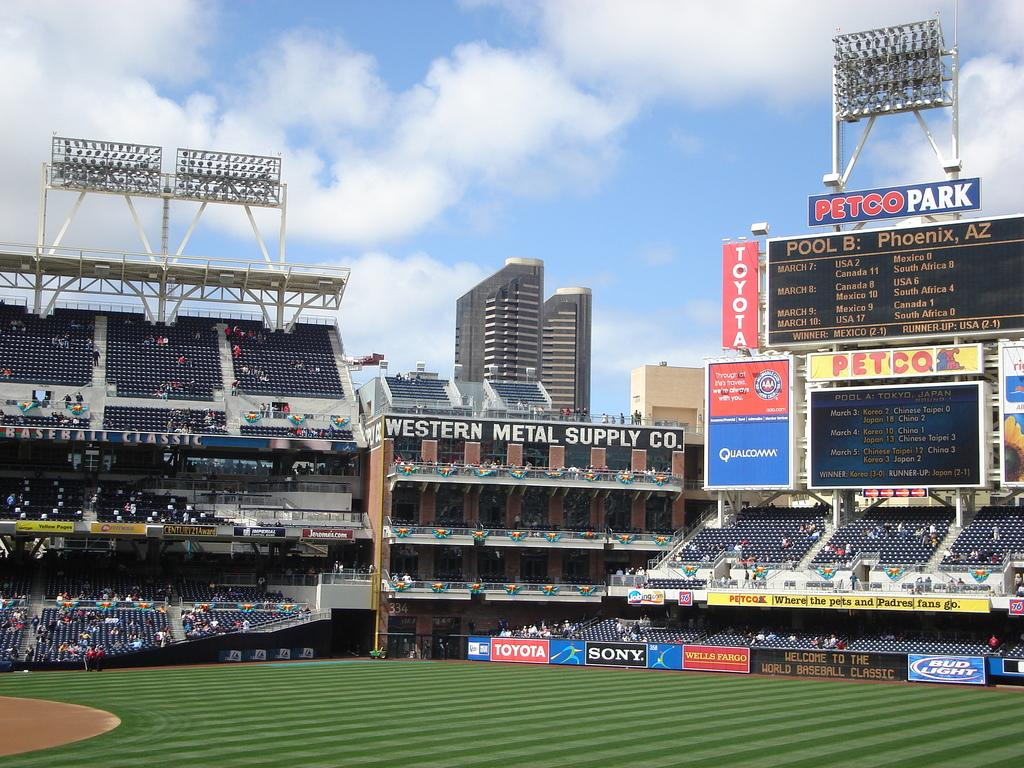<image>
Describe the image concisely. Petco Park has many empty seats on game day. 